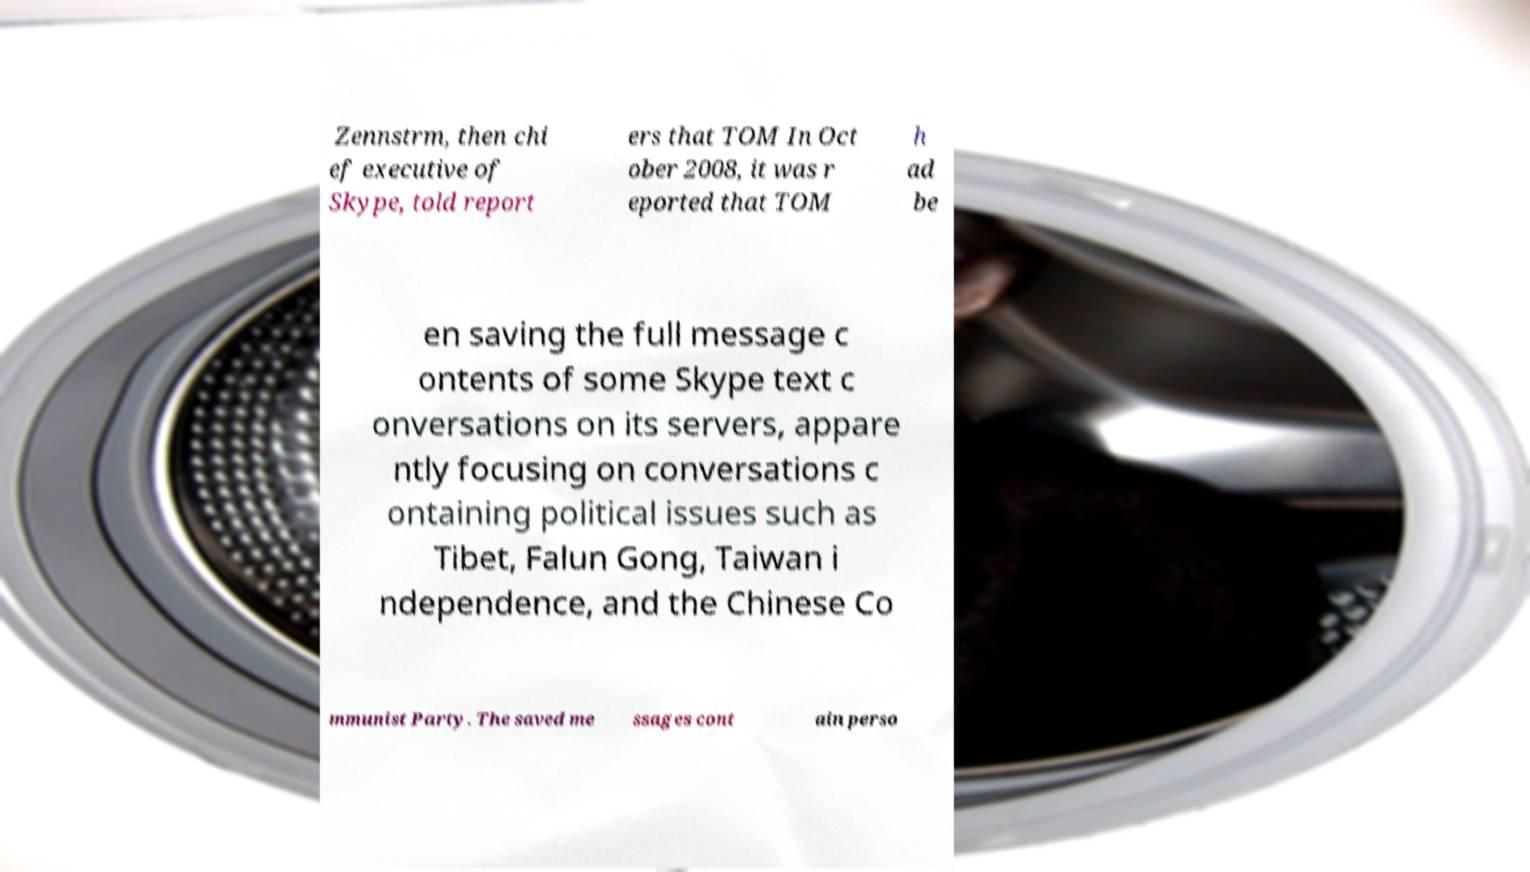What messages or text are displayed in this image? I need them in a readable, typed format. Zennstrm, then chi ef executive of Skype, told report ers that TOM In Oct ober 2008, it was r eported that TOM h ad be en saving the full message c ontents of some Skype text c onversations on its servers, appare ntly focusing on conversations c ontaining political issues such as Tibet, Falun Gong, Taiwan i ndependence, and the Chinese Co mmunist Party. The saved me ssages cont ain perso 